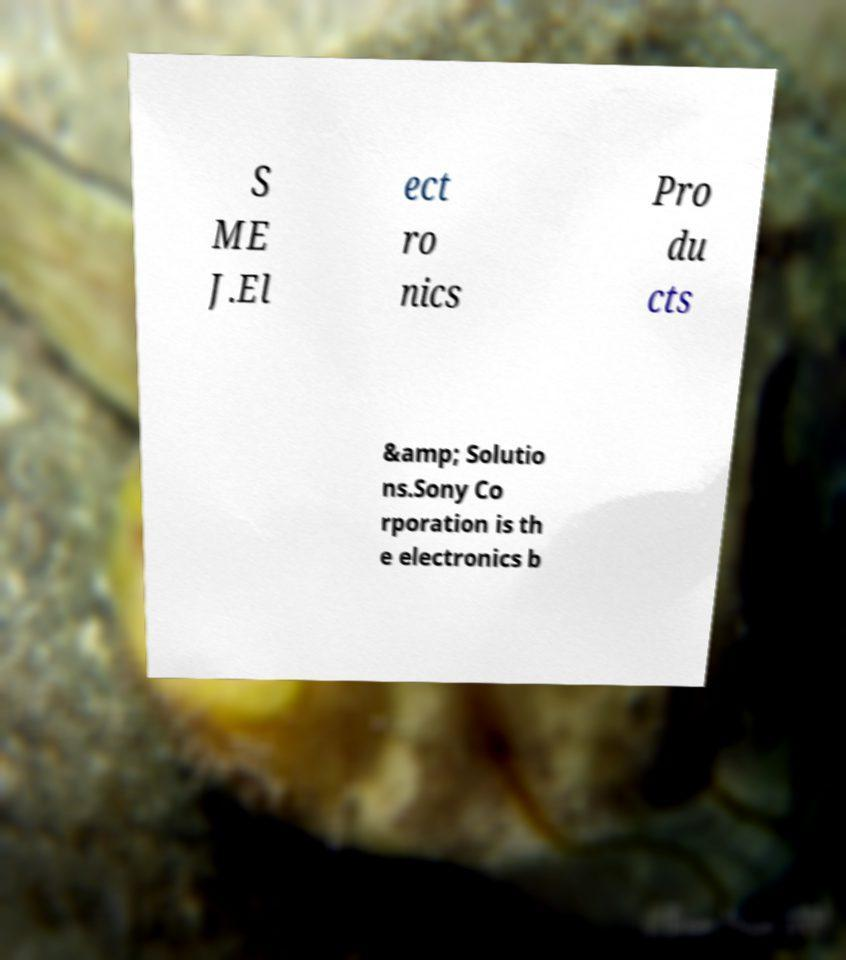There's text embedded in this image that I need extracted. Can you transcribe it verbatim? S ME J.El ect ro nics Pro du cts &amp; Solutio ns.Sony Co rporation is th e electronics b 